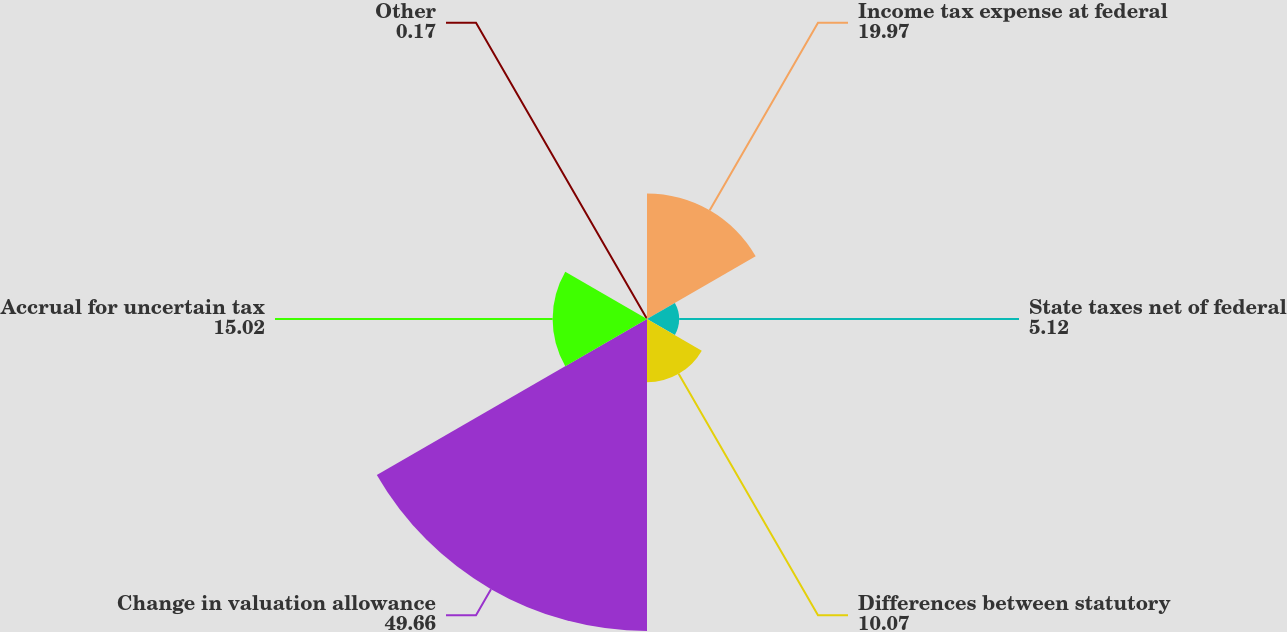<chart> <loc_0><loc_0><loc_500><loc_500><pie_chart><fcel>Income tax expense at federal<fcel>State taxes net of federal<fcel>Differences between statutory<fcel>Change in valuation allowance<fcel>Accrual for uncertain tax<fcel>Other<nl><fcel>19.97%<fcel>5.12%<fcel>10.07%<fcel>49.66%<fcel>15.02%<fcel>0.17%<nl></chart> 